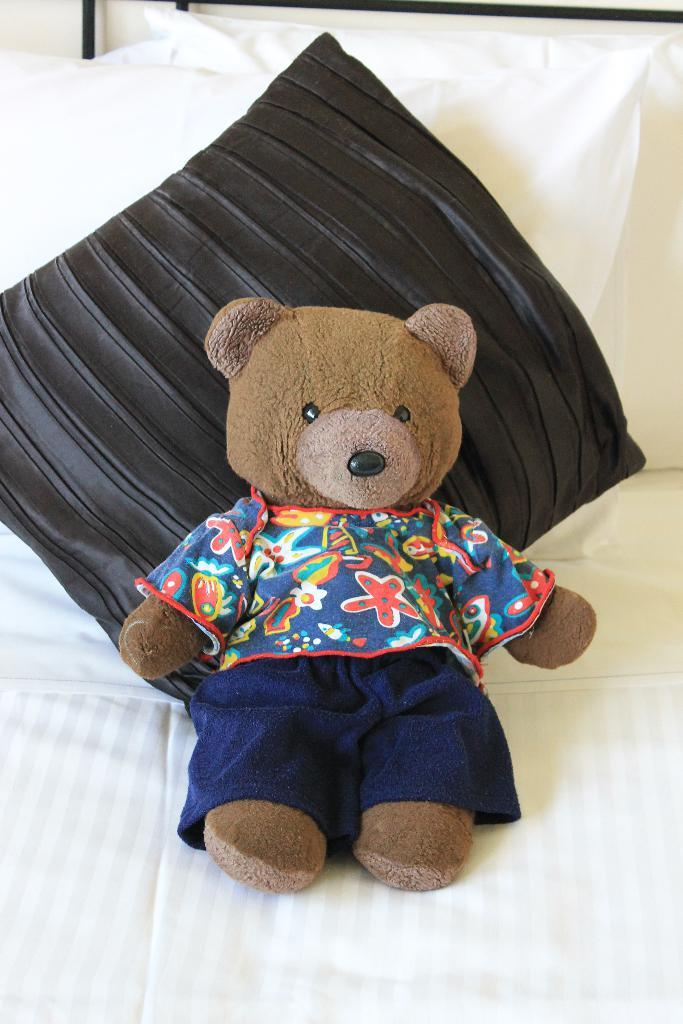What is the main subject in the image? There is a doll in the image. What can be observed about the doll's appearance? The doll has clothes on. Where is the doll located in the image? The doll is on a bed. What else can be seen on the bed? There are pillows in the image. What feature of the bed is mentioned in the facts? There are rods at the back of the bed. What direction is the servant facing in the image? There is no servant present in the image. Is there any coal visible in the image? There is no coal present in the image. 